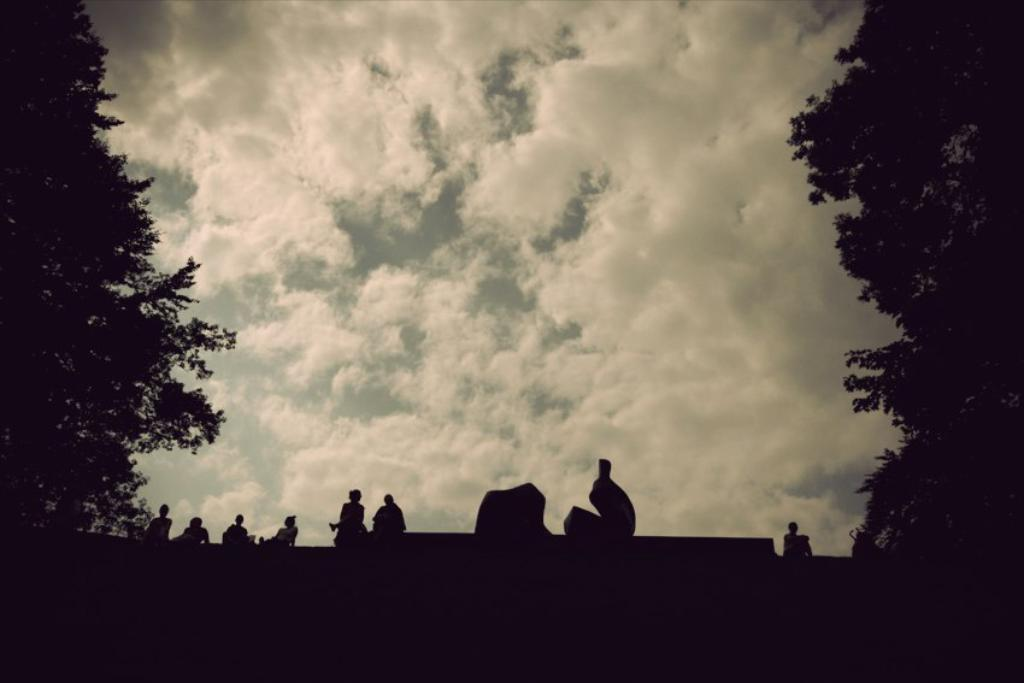How many persons are in the image? There are persons in the image. What can be seen on the left side of the image? There is a tree on the left side of the image. What can be seen on the right side of the image? There is a tree on the right side of the image. What is visible in the sky in the image? There are clouds in the sky. What news is being reported by the tree on the left side of the image? There is no news being reported in the image, as the trees are not capable of reporting news. 